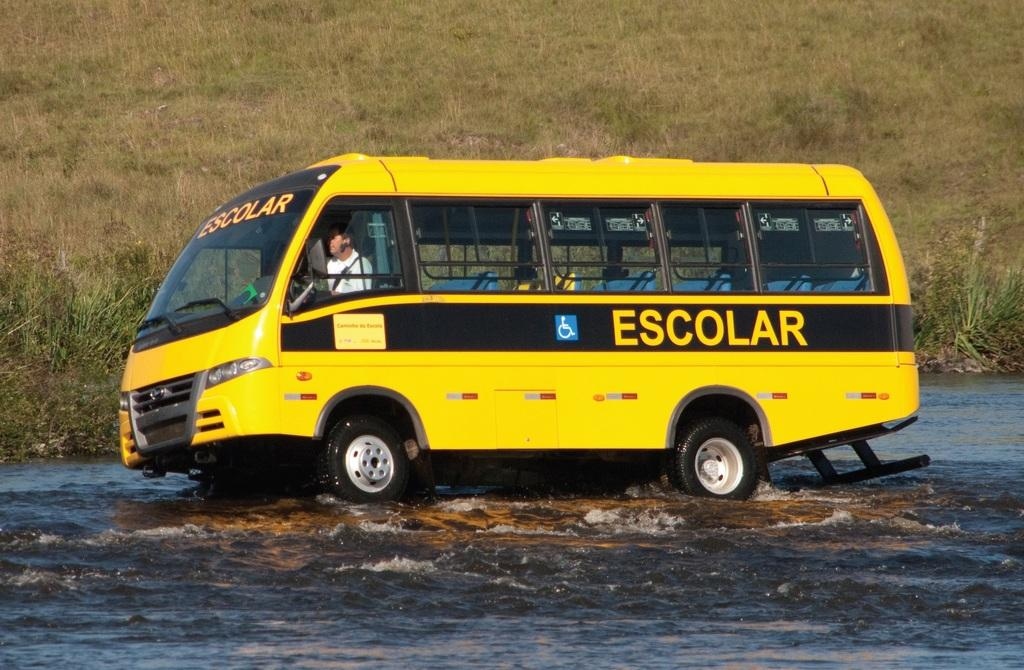Provide a one-sentence caption for the provided image. The yellow bus Escolar is driving through high water. 